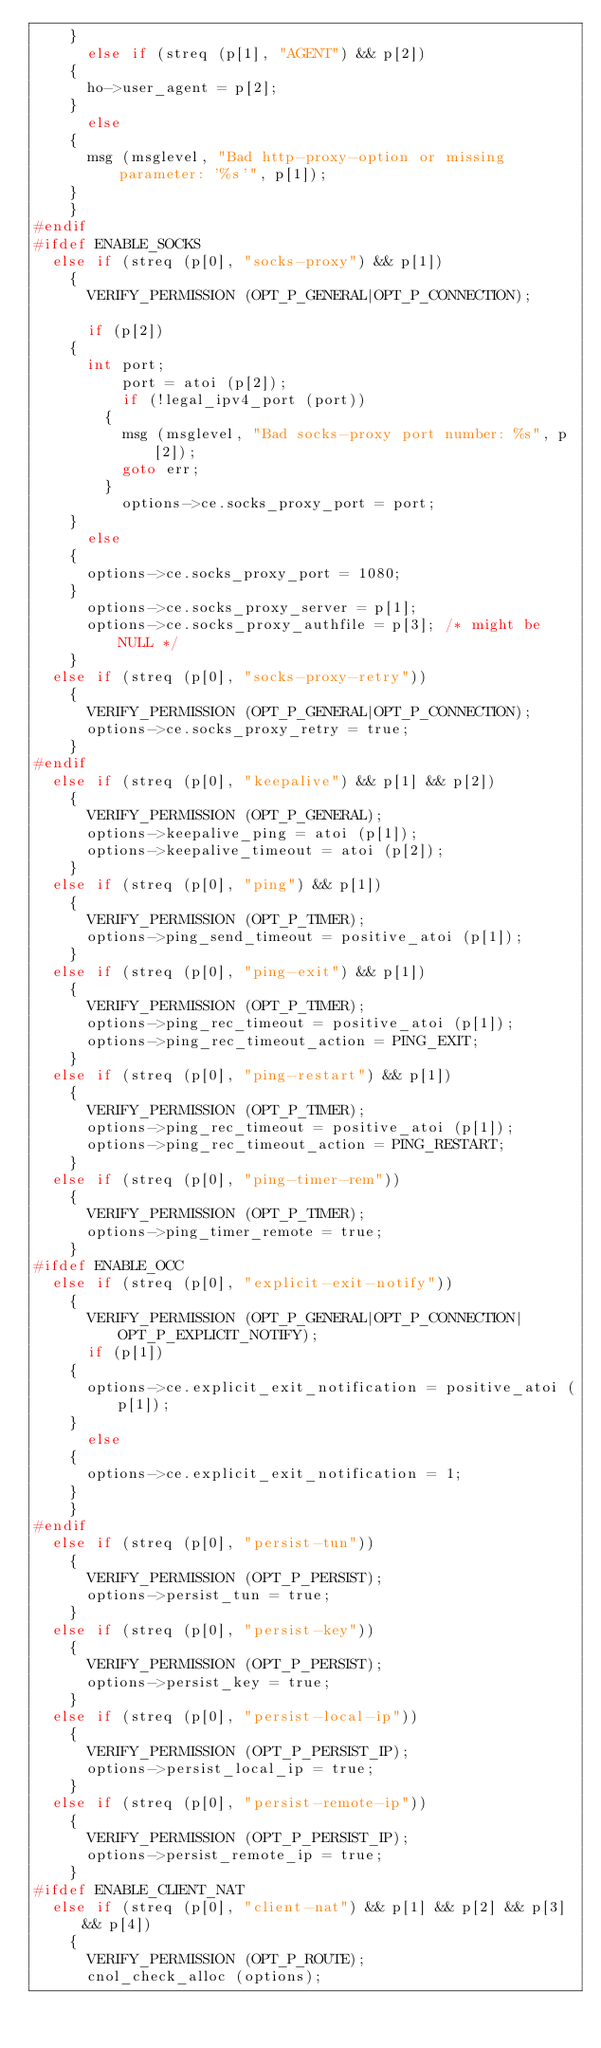<code> <loc_0><loc_0><loc_500><loc_500><_C_>	}
      else if (streq (p[1], "AGENT") && p[2])
	{
	  ho->user_agent = p[2];
	}
      else
	{
	  msg (msglevel, "Bad http-proxy-option or missing parameter: '%s'", p[1]);
	}
    }
#endif
#ifdef ENABLE_SOCKS
  else if (streq (p[0], "socks-proxy") && p[1])
    {
      VERIFY_PERMISSION (OPT_P_GENERAL|OPT_P_CONNECTION);

      if (p[2])
	{
	  int port;
          port = atoi (p[2]);
          if (!legal_ipv4_port (port))
	    {
	      msg (msglevel, "Bad socks-proxy port number: %s", p[2]);
	      goto err;
	    }
          options->ce.socks_proxy_port = port;
	}
      else
	{
	  options->ce.socks_proxy_port = 1080;
	}
      options->ce.socks_proxy_server = p[1];
      options->ce.socks_proxy_authfile = p[3]; /* might be NULL */
    }
  else if (streq (p[0], "socks-proxy-retry"))
    {
      VERIFY_PERMISSION (OPT_P_GENERAL|OPT_P_CONNECTION);
      options->ce.socks_proxy_retry = true;
    }
#endif
  else if (streq (p[0], "keepalive") && p[1] && p[2])
    {
      VERIFY_PERMISSION (OPT_P_GENERAL);
      options->keepalive_ping = atoi (p[1]);
      options->keepalive_timeout = atoi (p[2]);
    }
  else if (streq (p[0], "ping") && p[1])
    {
      VERIFY_PERMISSION (OPT_P_TIMER);
      options->ping_send_timeout = positive_atoi (p[1]);
    }
  else if (streq (p[0], "ping-exit") && p[1])
    {
      VERIFY_PERMISSION (OPT_P_TIMER);
      options->ping_rec_timeout = positive_atoi (p[1]);
      options->ping_rec_timeout_action = PING_EXIT;
    }
  else if (streq (p[0], "ping-restart") && p[1])
    {
      VERIFY_PERMISSION (OPT_P_TIMER);
      options->ping_rec_timeout = positive_atoi (p[1]);
      options->ping_rec_timeout_action = PING_RESTART;
    }
  else if (streq (p[0], "ping-timer-rem"))
    {
      VERIFY_PERMISSION (OPT_P_TIMER);
      options->ping_timer_remote = true;
    }
#ifdef ENABLE_OCC
  else if (streq (p[0], "explicit-exit-notify"))
    {
      VERIFY_PERMISSION (OPT_P_GENERAL|OPT_P_CONNECTION|OPT_P_EXPLICIT_NOTIFY);
      if (p[1])
	{
	  options->ce.explicit_exit_notification = positive_atoi (p[1]);
	}
      else
	{
	  options->ce.explicit_exit_notification = 1;
	}
    }
#endif
  else if (streq (p[0], "persist-tun"))
    {
      VERIFY_PERMISSION (OPT_P_PERSIST);
      options->persist_tun = true;
    }
  else if (streq (p[0], "persist-key"))
    {
      VERIFY_PERMISSION (OPT_P_PERSIST);
      options->persist_key = true;
    }
  else if (streq (p[0], "persist-local-ip"))
    {
      VERIFY_PERMISSION (OPT_P_PERSIST_IP);
      options->persist_local_ip = true;
    }
  else if (streq (p[0], "persist-remote-ip"))
    {
      VERIFY_PERMISSION (OPT_P_PERSIST_IP);
      options->persist_remote_ip = true;
    }
#ifdef ENABLE_CLIENT_NAT
  else if (streq (p[0], "client-nat") && p[1] && p[2] && p[3] && p[4])
    {
      VERIFY_PERMISSION (OPT_P_ROUTE);
      cnol_check_alloc (options);</code> 